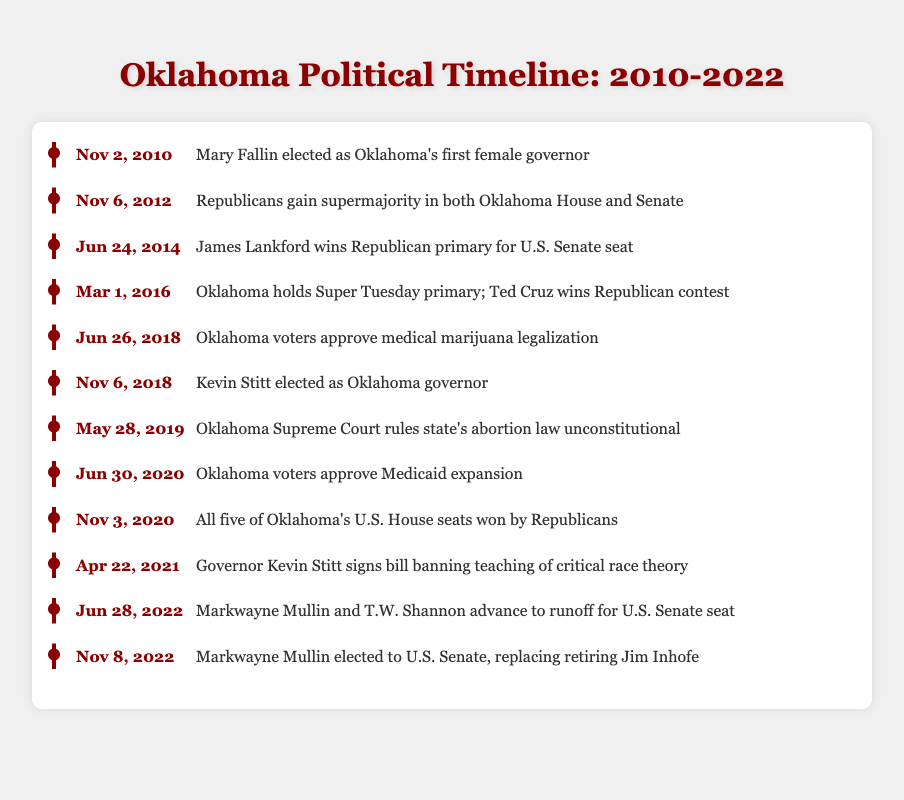What significant political event occurred on November 2, 2010? The table states that Mary Fallin was elected as Oklahoma's first female governor on this date, making it a notable political event.
Answer: Mary Fallin elected as Oklahoma's first female governor Which party gained a supermajority in both the Oklahoma House and Senate on November 6, 2012? According to the table, Republicans gained a supermajority in both the Oklahoma House and Senate on this date, indicating their strong political influence at that time.
Answer: Republicans How many events related to the U.S. Senate took place in Oklahoma between 2014 and 2022? Reviewing the timeline, there are three events related to the U.S. Senate: James Lankford’s primary victory in 2014, the runoff between Markwayne Mullin and T.W. Shannon in 2022, and Markwayne Mullin's election to the Senate in 2022, thus totaling to three events.
Answer: 3 Did the Oklahoma Supreme Court rule the state's abortion law unconstitutional on May 28, 2019? The table confirms that the Oklahoma Supreme Court did indeed rule the state's abortion law unconstitutional on this date, indicating a significant legal decision.
Answer: Yes What is the total number of years between the election of Mary Fallin as governor and the election of Markwayne Mullin to the U.S. Senate? The timeline shows that Mary Fallin was elected on November 2, 2010, and Markwayne Mullin was elected on November 8, 2022. The total time between these dates is 12 years, from 2010 to 2022, counting the months indicates it is slightly less than 12 years but can be rounded to 12 years for simplicity.
Answer: 12 years How many political events mentioned in the timeline occurred in the year 2020? From the table, we see two events listed for 2020: Medicaid expansion approval and all five U.S. House seats won by Republicans. Therefore, the total is two events.
Answer: 2 Which governor signed the bill banning the teaching of critical race theory, and when did this happen? According to the timeline, Governor Kevin Stitt signed the bill banning the teaching of critical race theory on April 22, 2021, marking a significant legislative decision during his term.
Answer: Kevin Stitt, April 22, 2021 Was Kevin Stitt elected as Oklahoma governor before or after medical marijuana legalization in 2018? Looking at the timeline, Kevin Stitt was elected on November 6, 2018, which is after the approval of medical marijuana legalization that occurred on June 26, 2018. Thus, the sequence confirms he took office after this event.
Answer: After 